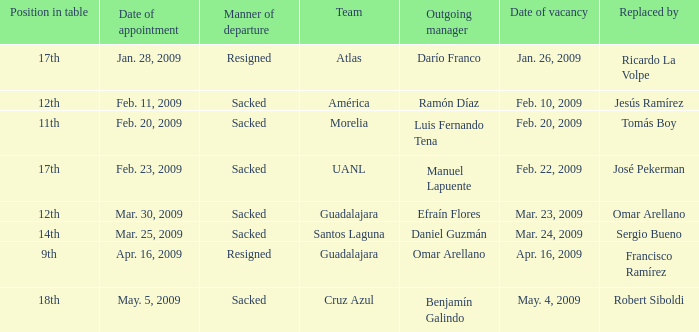What is Team, when Replaced By is "Omar Arellano"? Guadalajara. 